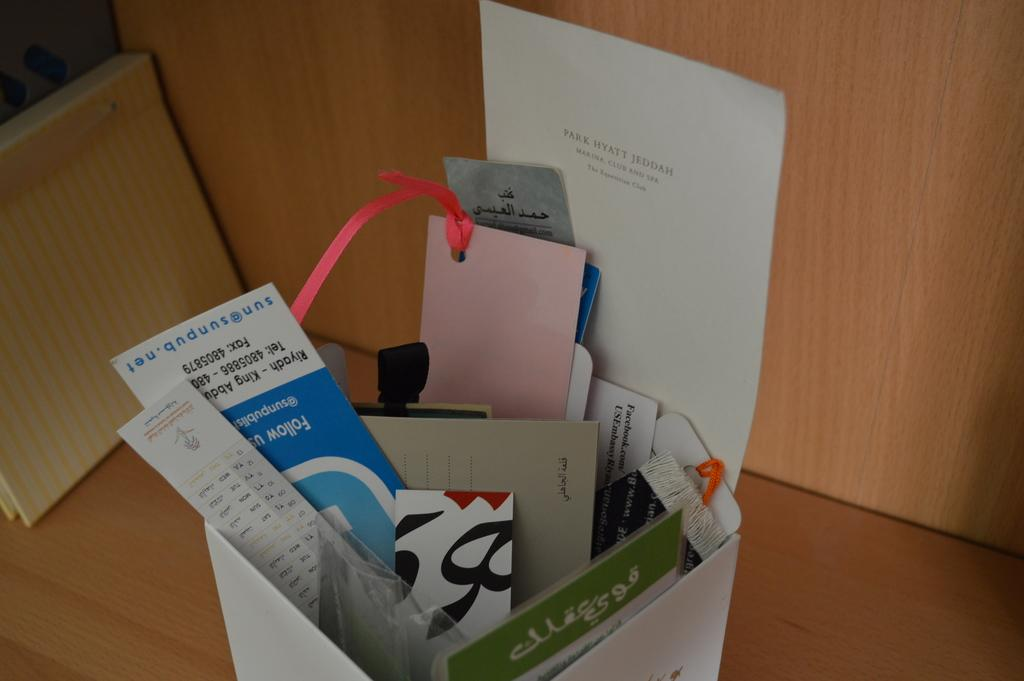<image>
Present a compact description of the photo's key features. A piece of paper from Park Hyatt Jeddah is next to a box of other papers. 